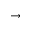Convert formula to latex. <formula><loc_0><loc_0><loc_500><loc_500>\rightarrow</formula> 